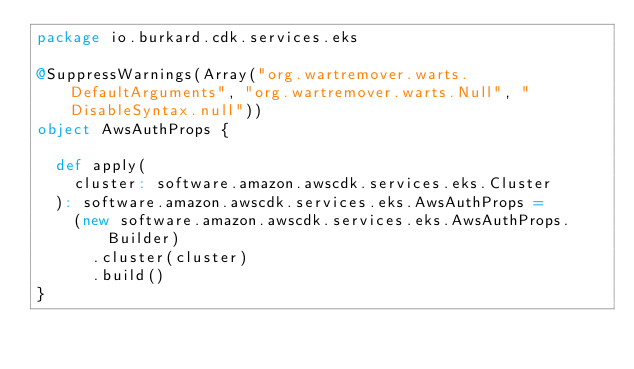Convert code to text. <code><loc_0><loc_0><loc_500><loc_500><_Scala_>package io.burkard.cdk.services.eks

@SuppressWarnings(Array("org.wartremover.warts.DefaultArguments", "org.wartremover.warts.Null", "DisableSyntax.null"))
object AwsAuthProps {

  def apply(
    cluster: software.amazon.awscdk.services.eks.Cluster
  ): software.amazon.awscdk.services.eks.AwsAuthProps =
    (new software.amazon.awscdk.services.eks.AwsAuthProps.Builder)
      .cluster(cluster)
      .build()
}
</code> 